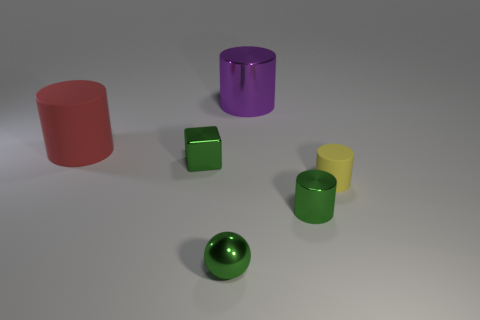Subtract all purple shiny cylinders. How many cylinders are left? 3 Subtract all spheres. How many objects are left? 5 Subtract 1 balls. How many balls are left? 0 Subtract all yellow balls. Subtract all green cylinders. How many balls are left? 1 Subtract all purple blocks. How many purple cylinders are left? 1 Subtract all green metallic blocks. Subtract all tiny yellow matte cylinders. How many objects are left? 4 Add 4 red objects. How many red objects are left? 5 Add 6 big red rubber things. How many big red rubber things exist? 7 Add 3 big cyan shiny cylinders. How many objects exist? 9 Subtract all yellow cylinders. How many cylinders are left? 3 